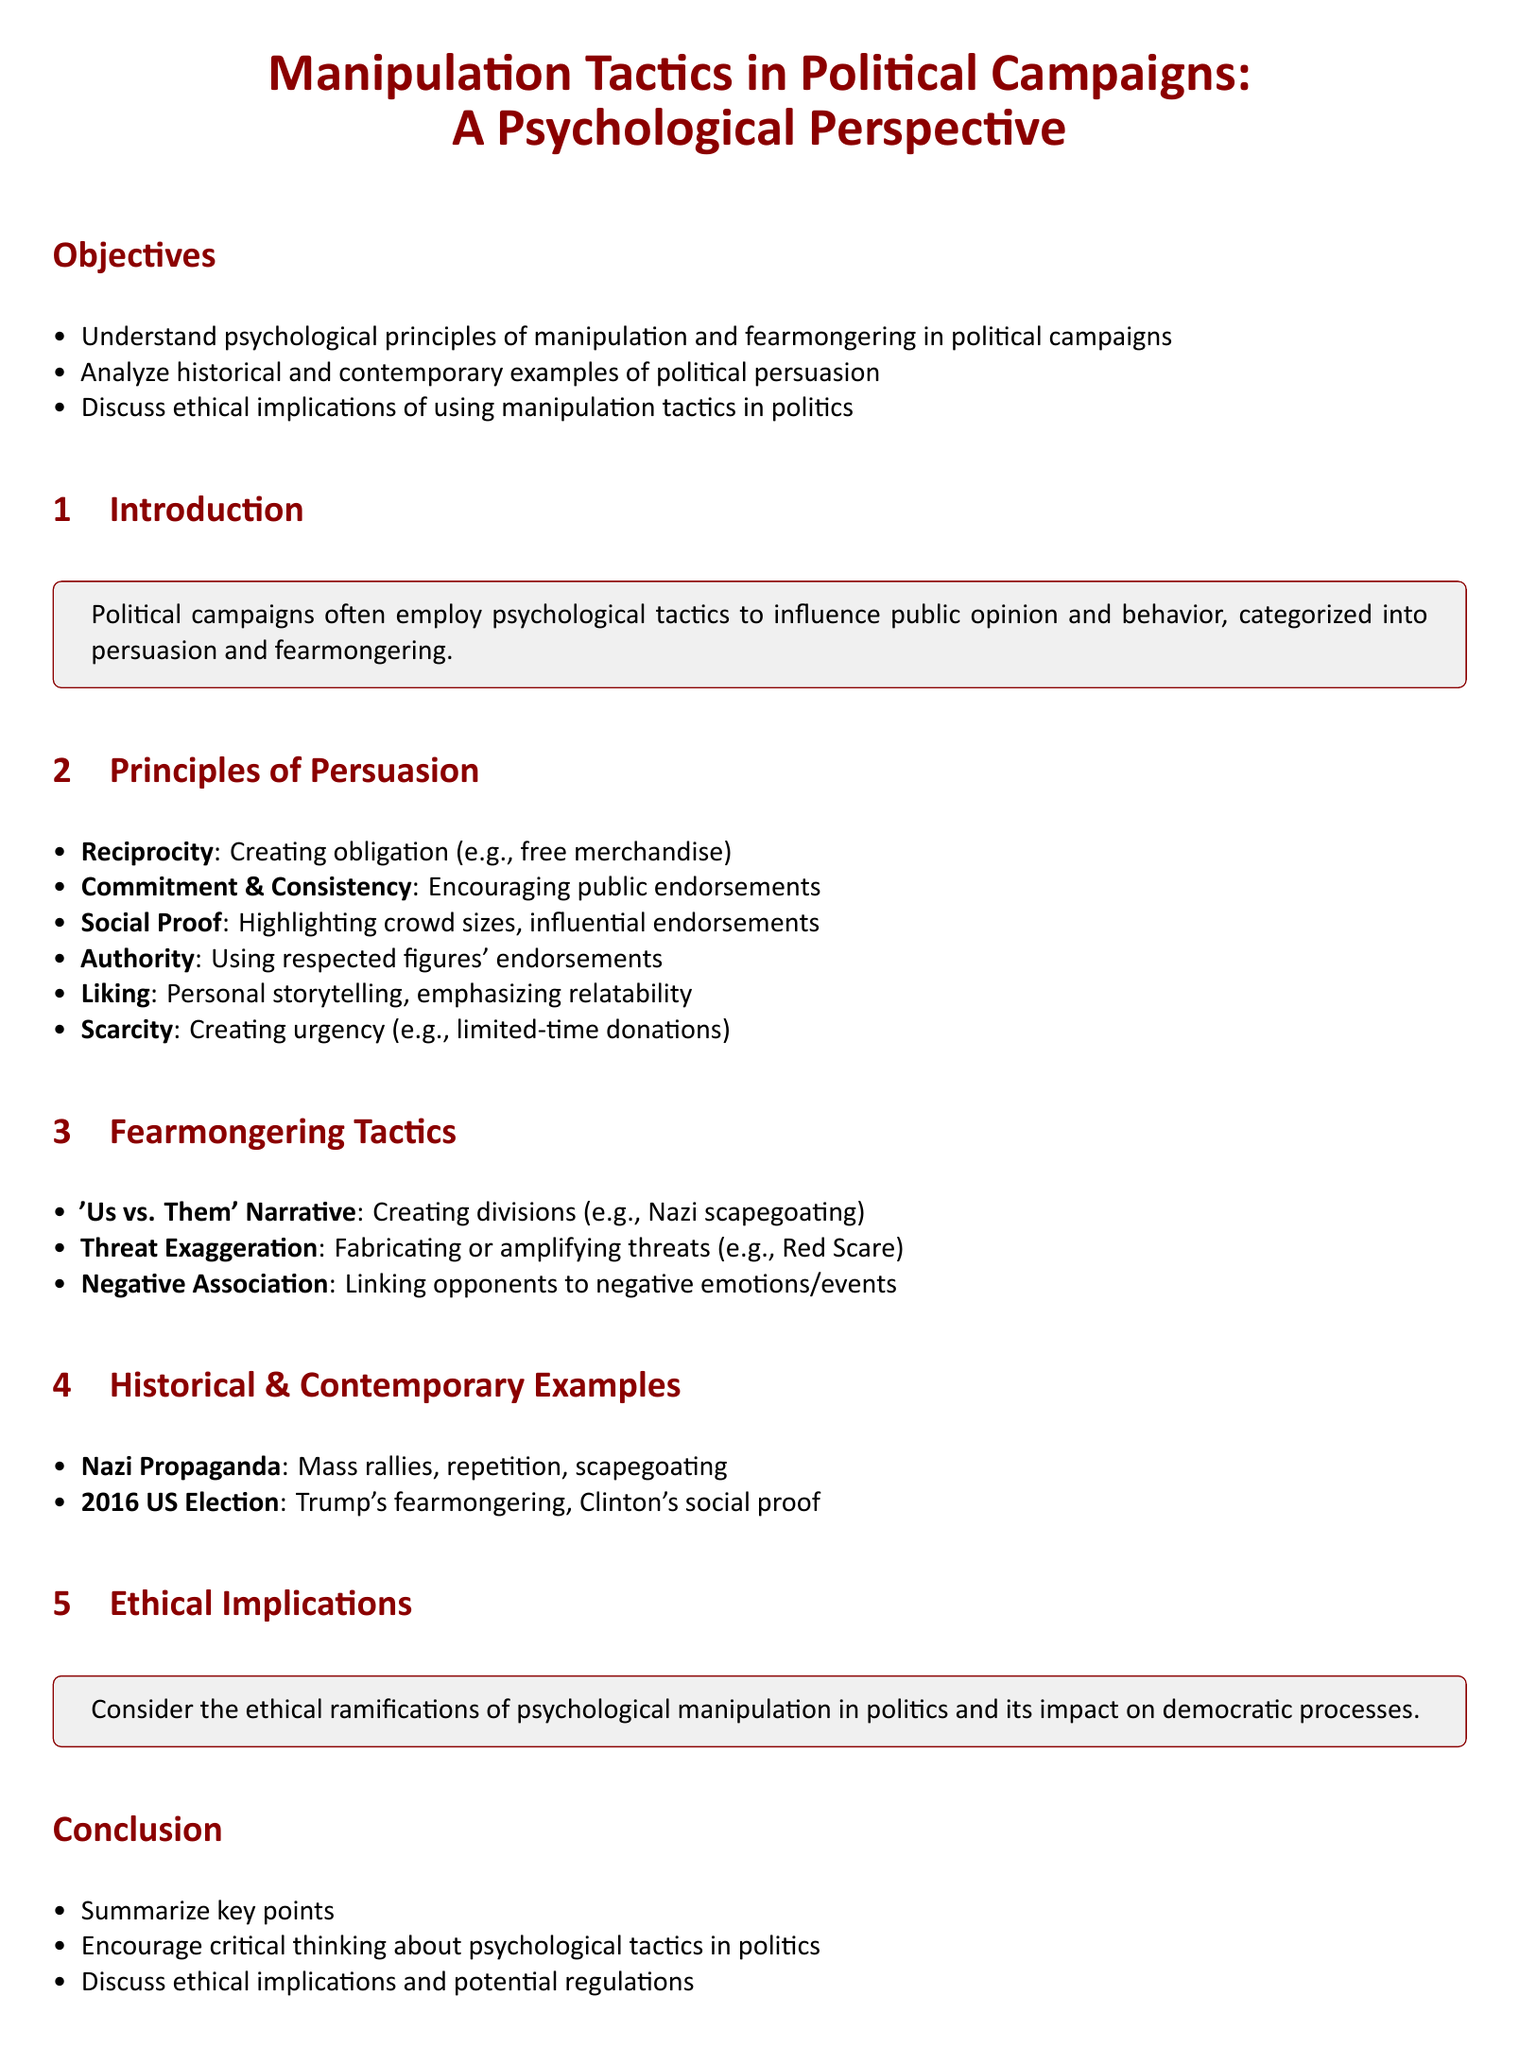What are the two main categories of tactics used in political campaigns? The document states that political campaigns employ psychological tactics categorized into persuasion and fearmongering.
Answer: persuasion and fearmongering What principle involves creating obligation through free merchandise? The principle described in the document that relates to creating obligation is reciprocity.
Answer: reciprocity Which historical example is mentioned regarding threatening exaggeration? The document provides the example of the Red Scare as an instance of threat exaggeration.
Answer: Red Scare What is a key ethical consideration discussed in the lesson plan? The document highlights the consideration of the ethical ramifications of psychological manipulation in politics.
Answer: ethical ramifications What is the main intention of the 'Us vs. Them' narrative? According to the document, the aim of this narrative is to create divisions.
Answer: create divisions Which campaign utilized fearmongering in the 2016 US election? The document specifies that Trump's campaign is an example of fearmongering from the 2016 US election.
Answer: Trump's campaign How many principles of persuasion are listed in the document? The document enumerates six principles of persuasion.
Answer: six What are the intended outcomes of the lesson plan? The objectives section outlines that understanding psychological principles and analyzing examples are intended outcomes.
Answer: understanding psychological principles, analyzing examples What type of examples are discussed in the section about Historical & Contemporary Examples? Historical and contemporary examples analyzed include those from Nazi Propaganda and the 2016 US election.
Answer: Nazi Propaganda and 2016 US election 